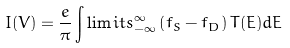Convert formula to latex. <formula><loc_0><loc_0><loc_500><loc_500>I ( V ) = \frac { e } { \pi } \int \lim i t s _ { - \infty } ^ { \infty } \left ( f _ { S } - f _ { D } \right ) T ( E ) d E</formula> 